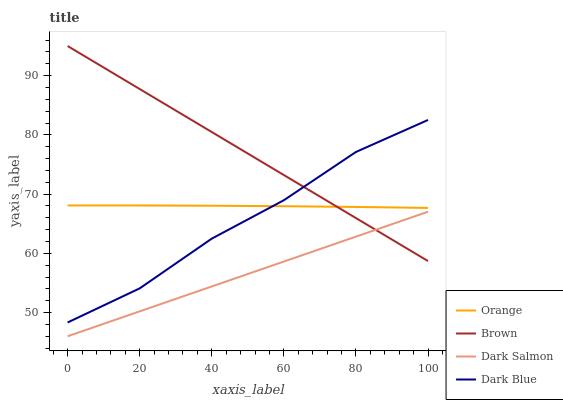Does Dark Salmon have the minimum area under the curve?
Answer yes or no. Yes. Does Brown have the maximum area under the curve?
Answer yes or no. Yes. Does Brown have the minimum area under the curve?
Answer yes or no. No. Does Dark Salmon have the maximum area under the curve?
Answer yes or no. No. Is Dark Salmon the smoothest?
Answer yes or no. Yes. Is Dark Blue the roughest?
Answer yes or no. Yes. Is Brown the smoothest?
Answer yes or no. No. Is Brown the roughest?
Answer yes or no. No. Does Dark Salmon have the lowest value?
Answer yes or no. Yes. Does Brown have the lowest value?
Answer yes or no. No. Does Brown have the highest value?
Answer yes or no. Yes. Does Dark Salmon have the highest value?
Answer yes or no. No. Is Dark Salmon less than Orange?
Answer yes or no. Yes. Is Orange greater than Dark Salmon?
Answer yes or no. Yes. Does Orange intersect Dark Blue?
Answer yes or no. Yes. Is Orange less than Dark Blue?
Answer yes or no. No. Is Orange greater than Dark Blue?
Answer yes or no. No. Does Dark Salmon intersect Orange?
Answer yes or no. No. 